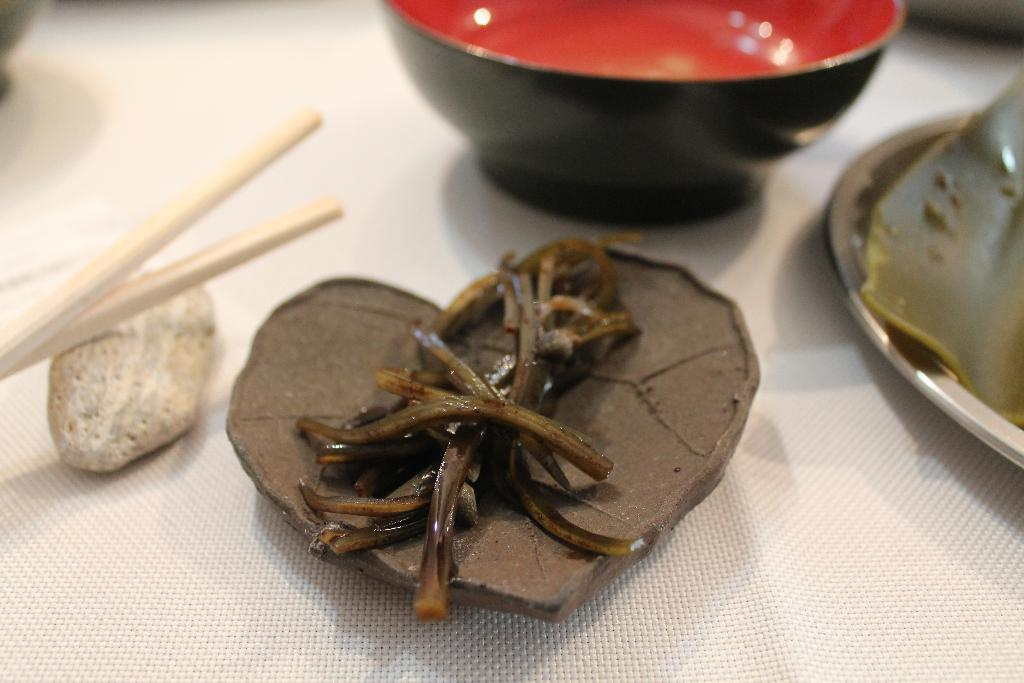What can be found on the table in the image? There are food items on the table. What utensils are present with the food items? Chopsticks are present in the table. What type of dish is located beside the food items? There is a bowl beside the food items. What other type of dish is located beside the food items? There is a plate beside the food items. What type of giraffe can be seen interacting with the food items in the image? There is no giraffe present in the image; it features food items, chopsticks, a bowl, and a plate on a table. What type of glue is used to hold the food items together in the image? There is no glue present in the image; the food items are not held together. 